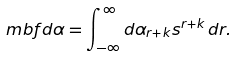<formula> <loc_0><loc_0><loc_500><loc_500>\ m b f d \alpha = \int _ { - \infty } ^ { \infty } d \alpha _ { r + k } s ^ { r + k } \, d r .</formula> 